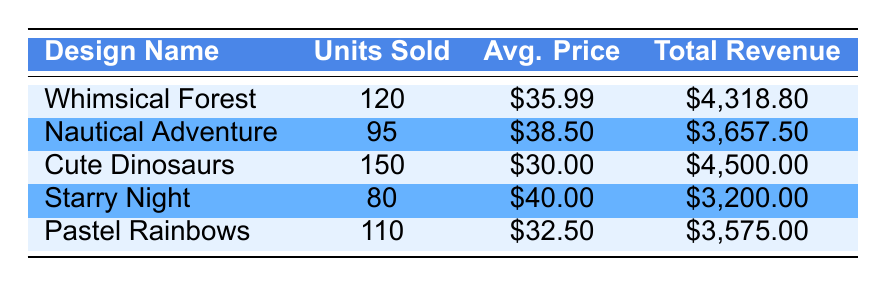What is the total revenue generated by the "Whimsical Forest" design? The total revenue for the "Whimsical Forest" design is directly listed in the table under the "Total Revenue" column. It states that the total revenue is 4318.80.
Answer: 4318.80 Which design had the highest units sold? By comparing the "Units Sold" column in the table, it is clear that the "Cute Dinosaurs" design has the highest figure at 150 units sold.
Answer: Cute Dinosaurs What is the average price per unit for the "Nautical Adventure" design? The average price per unit is presented in the "Avg. Price" column for the "Nautical Adventure" design, which is specified as 38.50.
Answer: 38.50 What is the total revenue for all designs combined? To find the total revenue, sum the "Total Revenue" values for each design: 4318.80 + 3657.50 + 4500.00 + 3200.00 + 3575.00 = 18851.30.
Answer: 18851.30 Is the average price per unit for "Starry Night" greater than for "Pastel Rainbows"? The average price for "Starry Night" is 40.00, while for "Pastel Rainbows" it is 32.50. Since 40.00 is greater than 32.50, the statement is true.
Answer: Yes What is the total revenue from designs that sold more than 100 units? The designs that sold more than 100 units are "Whimsical Forest" (4318.80), "Cute Dinosaurs" (4500.00), and "Pastel Rainbows" (3575.00). Adding these revenues gives: 4318.80 + 4500.00 + 3575.00 = 12393.80.
Answer: 12393.80 Which design had the lowest total revenue? By evaluating the "Total Revenue" column, "Starry Night" has the lowest total revenue of 3200.00.
Answer: Starry Night What is the average revenue per unit for the "Cute Dinosaurs" design? To find the average revenue per unit for this design, divide the total revenue (4500.00) by the units sold (150): 4500.00 / 150 = 30.00.
Answer: 30.00 Did any design generate a revenue greater than 4000? Checking the "Total Revenue" values, "Whimsical Forest" (4318.80) and "Cute Dinosaurs" (4500.00) both exceed 4000, thus the answer is yes.
Answer: Yes 